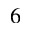<formula> <loc_0><loc_0><loc_500><loc_500>6</formula> 